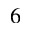<formula> <loc_0><loc_0><loc_500><loc_500>6</formula> 